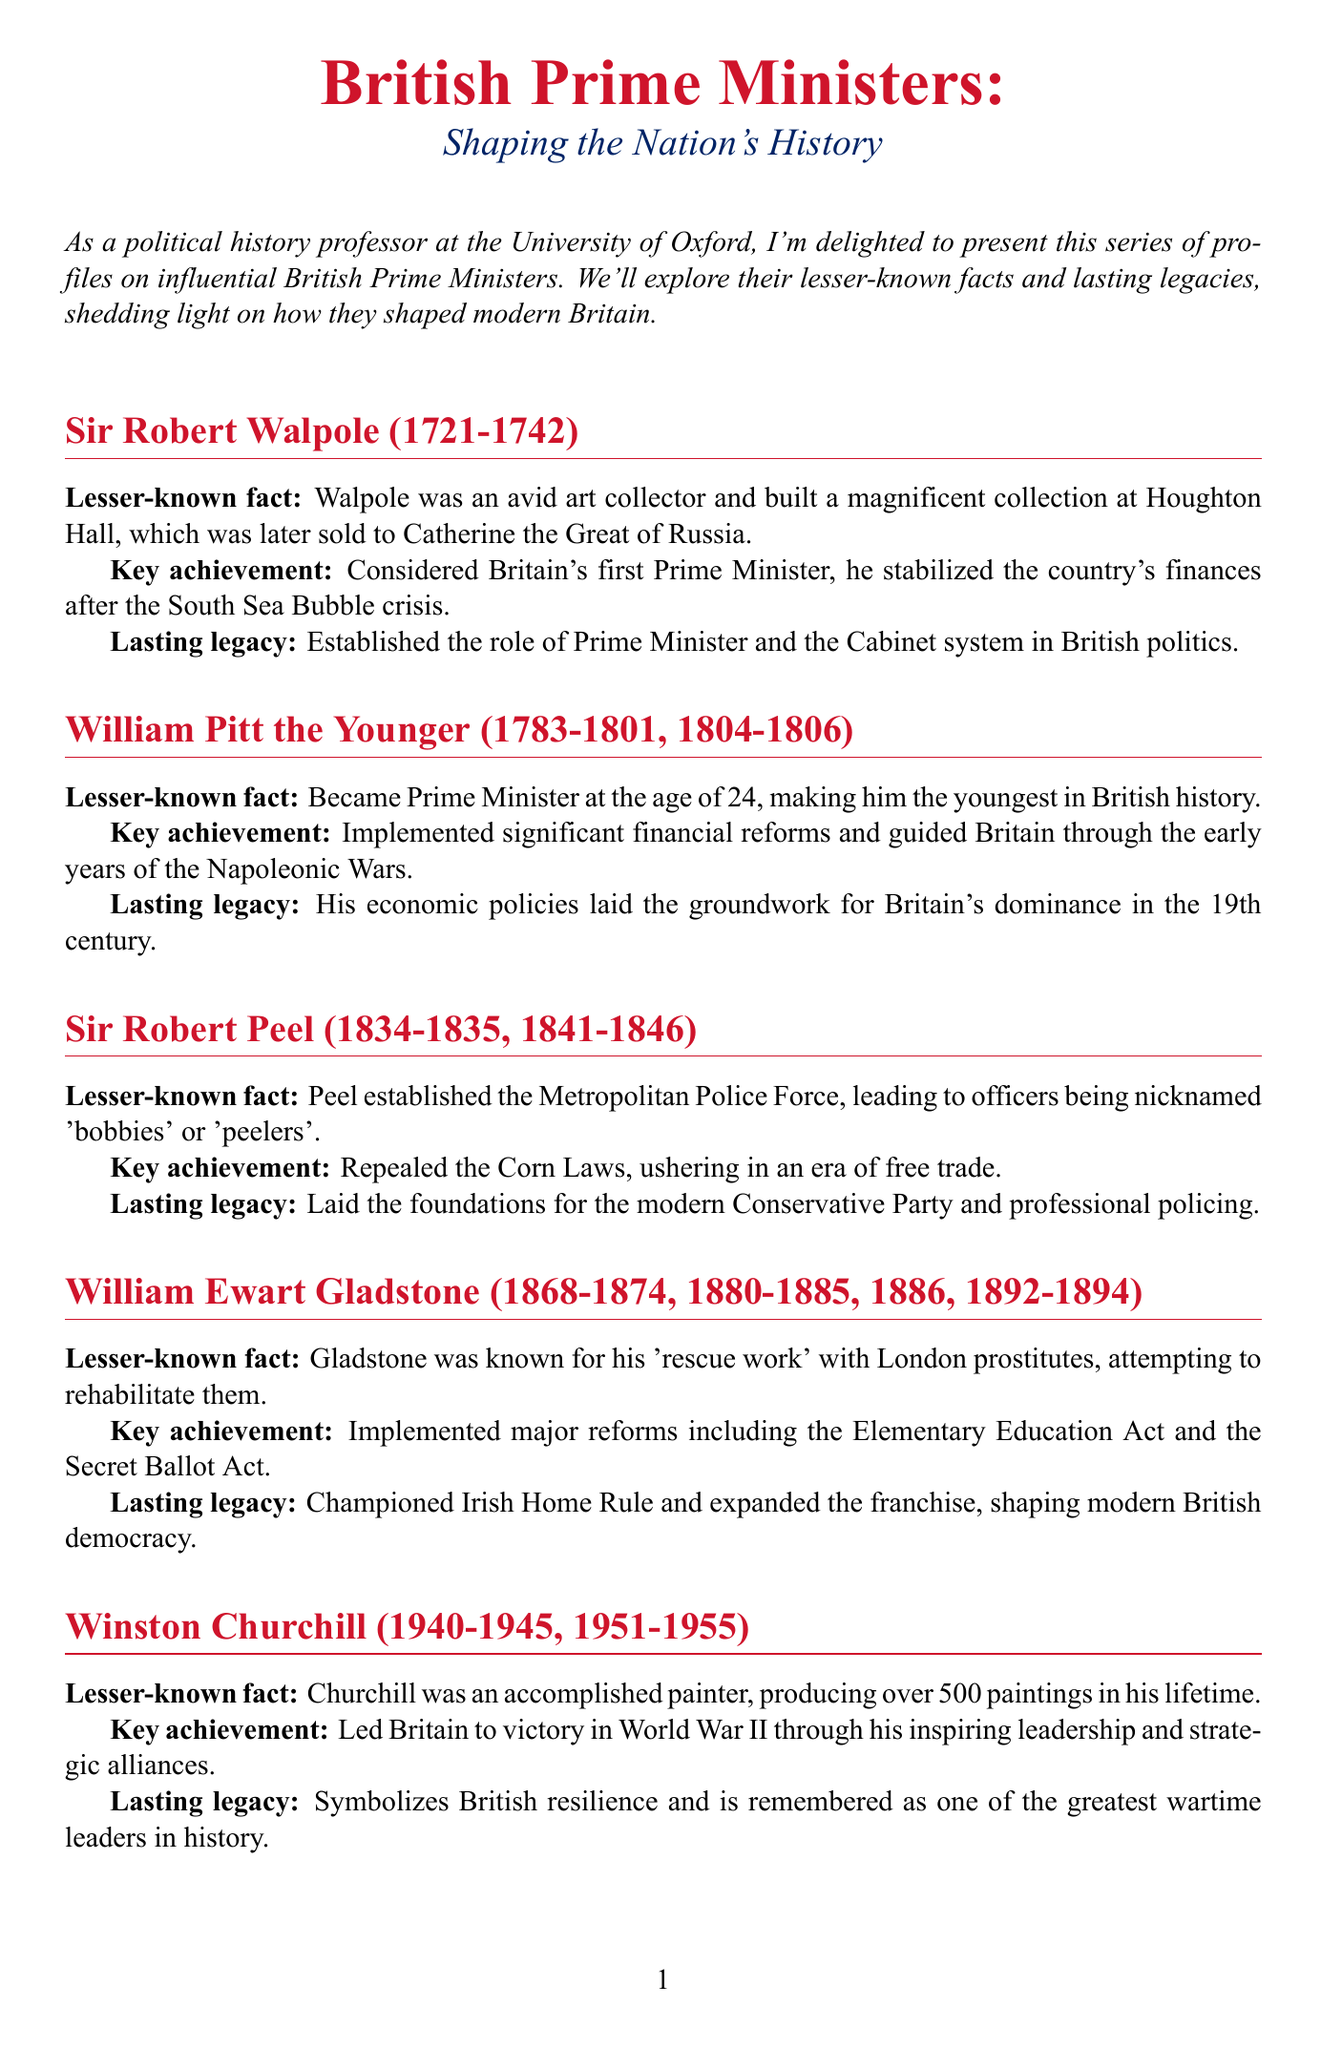What years did Sir Robert Walpole serve as Prime Minister? Sir Robert Walpole served from 1721 to 1742, which is stated in his profile in the document.
Answer: 1721-1742 Who was the youngest Prime Minister in British history? William Pitt the Younger is noted as becoming Prime Minister at the age of 24, making him the youngest in British history.
Answer: William Pitt the Younger What significant reform did Sir Robert Peel implement? The document mentions that he repealed the Corn Laws, which is a key achievement in his profile.
Answer: Repealed the Corn Laws Which Prime Minister is associated with the establishment of the Metropolitan Police Force? The profile of Sir Robert Peel indicates that he was responsible for establishing this police force.
Answer: Sir Robert Peel What is the lasting legacy of Margaret Thatcher as mentioned in the document? The document states her legacy included transforming the British economy and society, particularly through her policies known as 'Thatcherism'.
Answer: Transformed British economy and society What artistic talent did Winston Churchill have? The document notes that Churchill was a painter, producing over 500 paintings in his lifetime.
Answer: Painter How many times did William Ewart Gladstone serve as Prime Minister? The document lists the years he served, indicating he had four separate terms in office.
Answer: Four times 